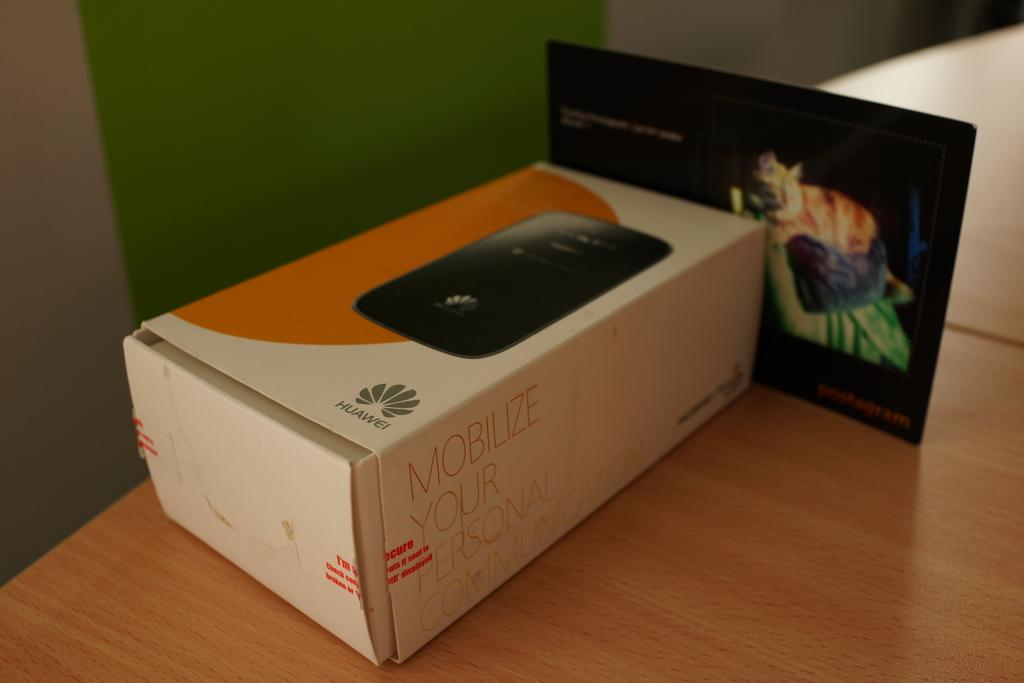<image>
Share a concise interpretation of the image provided. A Huawei product box with he words Mobilize your personal communication on the side. 